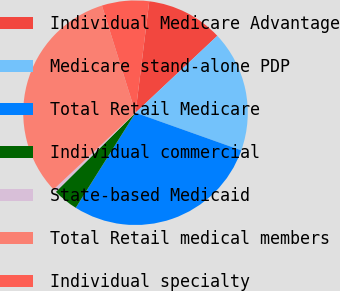Convert chart. <chart><loc_0><loc_0><loc_500><loc_500><pie_chart><fcel>Individual Medicare Advantage<fcel>Medicare stand-alone PDP<fcel>Total Retail Medicare<fcel>Individual commercial<fcel>State-based Medicaid<fcel>Total Retail medical members<fcel>Individual specialty<nl><fcel>11.04%<fcel>17.45%<fcel>28.49%<fcel>3.63%<fcel>0.46%<fcel>32.15%<fcel>6.79%<nl></chart> 